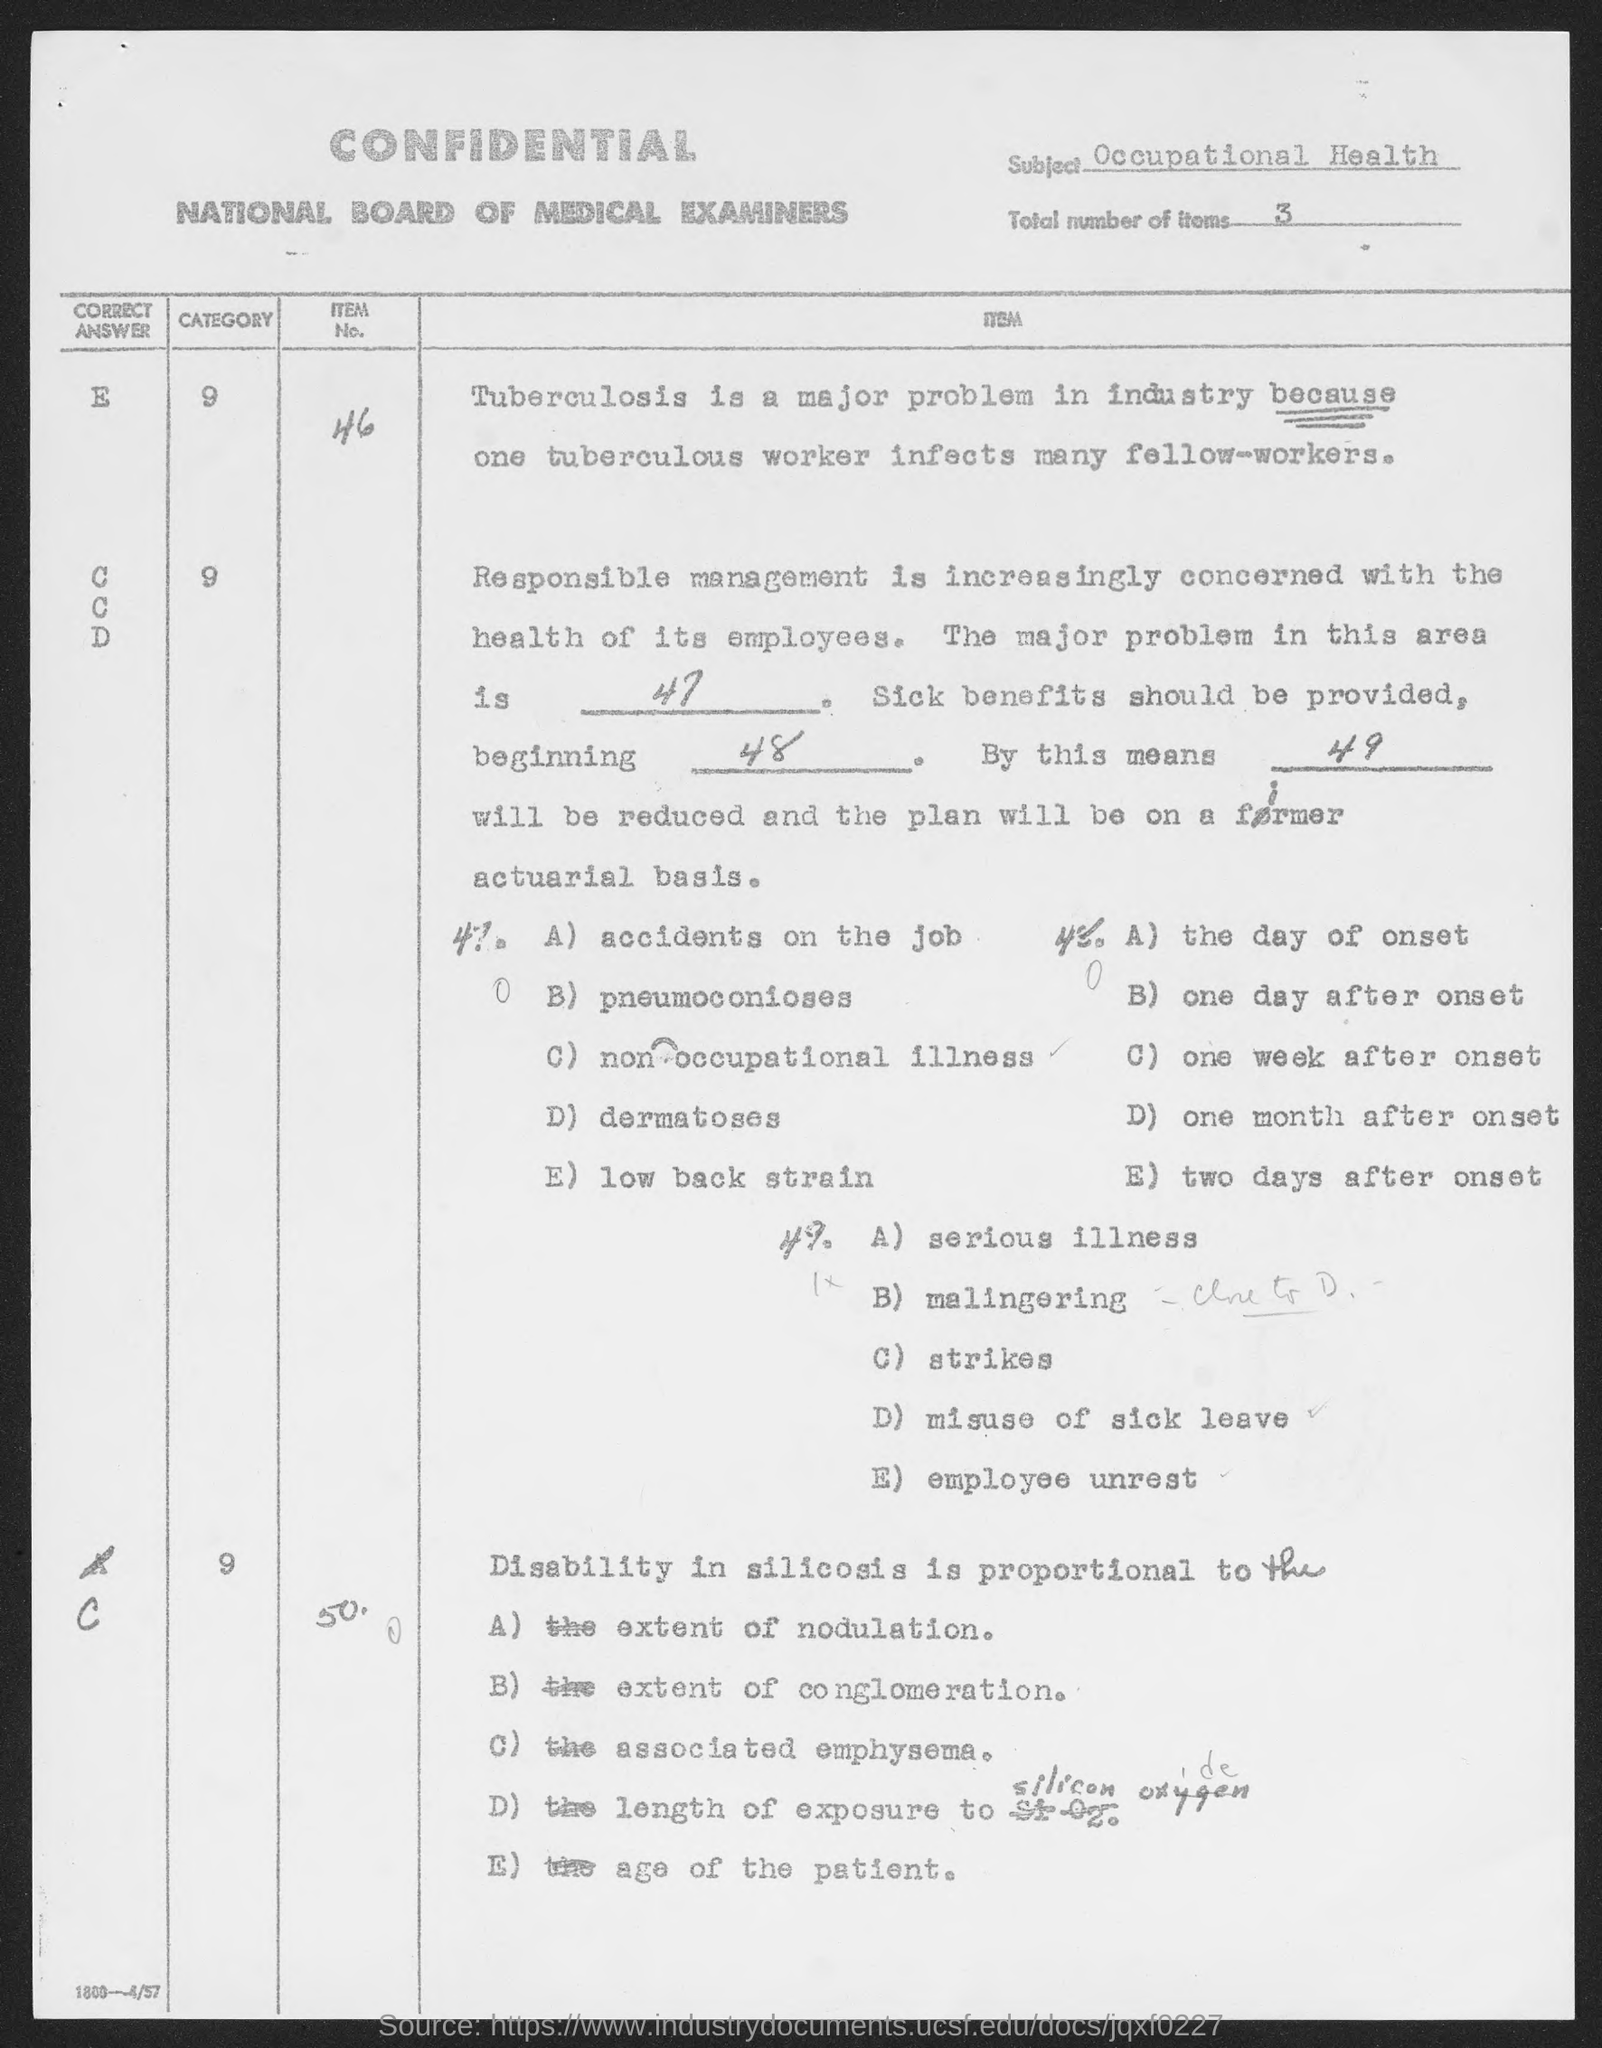Outline some significant characteristics in this image. The total number of items mentioned on the given page is 3. The subject mentioned in the given page is "Occupational Health. 